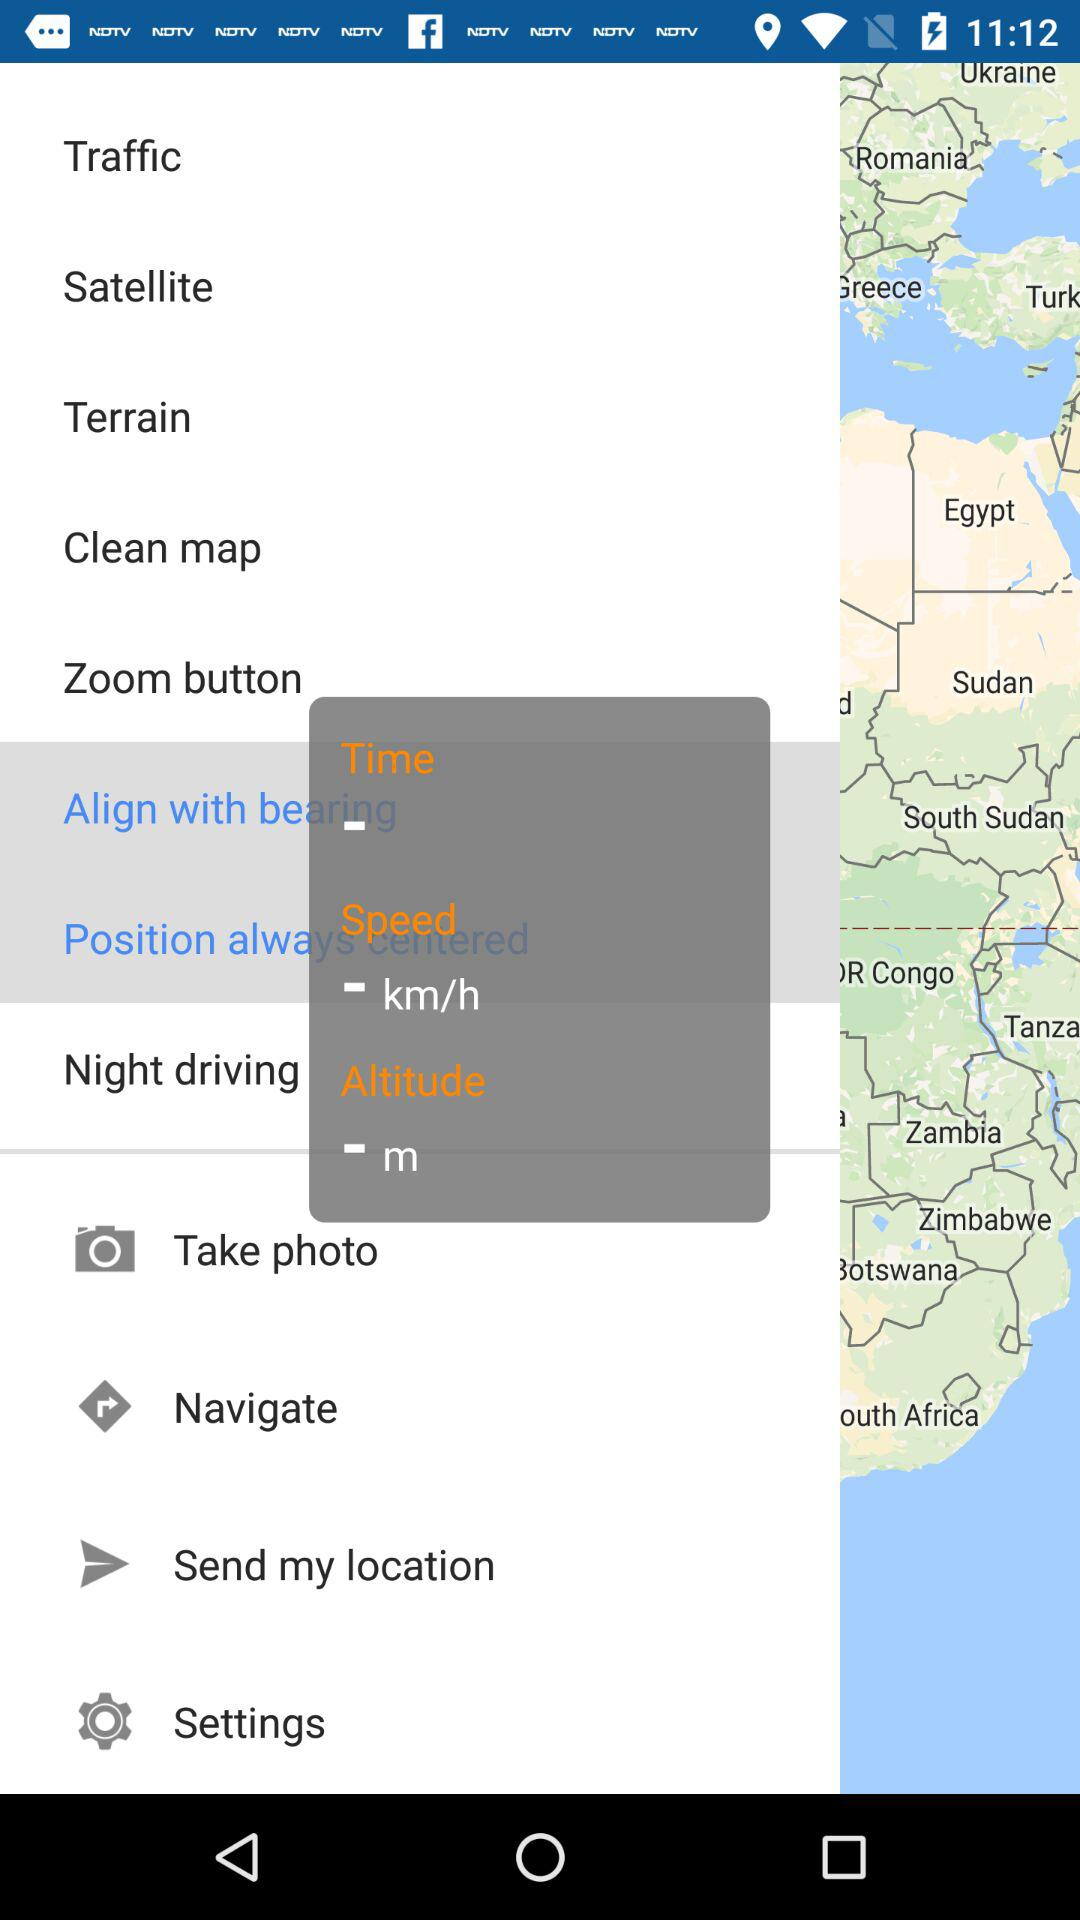Which option is selected?
When the provided information is insufficient, respond with <no answer>. <no answer> 